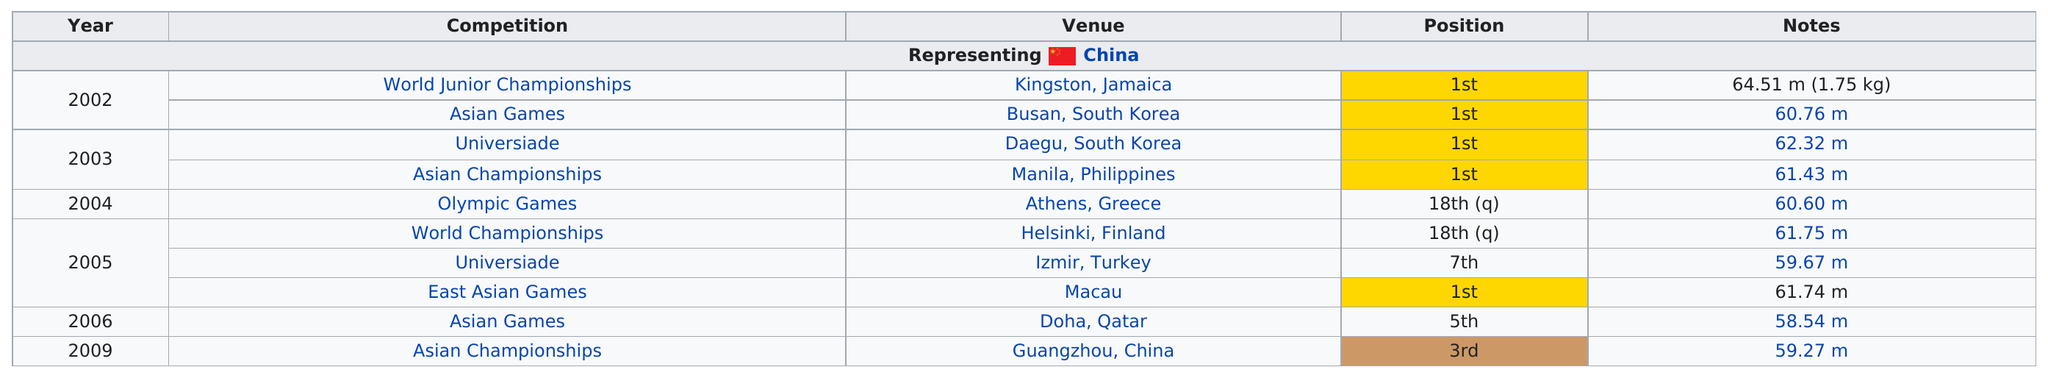Indicate a few pertinent items in this graphic. The World Junior Championships have the highest listed meters among all competitions. The difference in meters between the 2004 and 2009 competitions was 1.33... In the years 2002 and 2003, Wu Tao won first place in the competition consecutively. The 2009 Asian Championships were held in Guangzhou, China, and prior to that, they were hosted by Manila, Philippines. Wu Tao came in less than third position 4 times. 